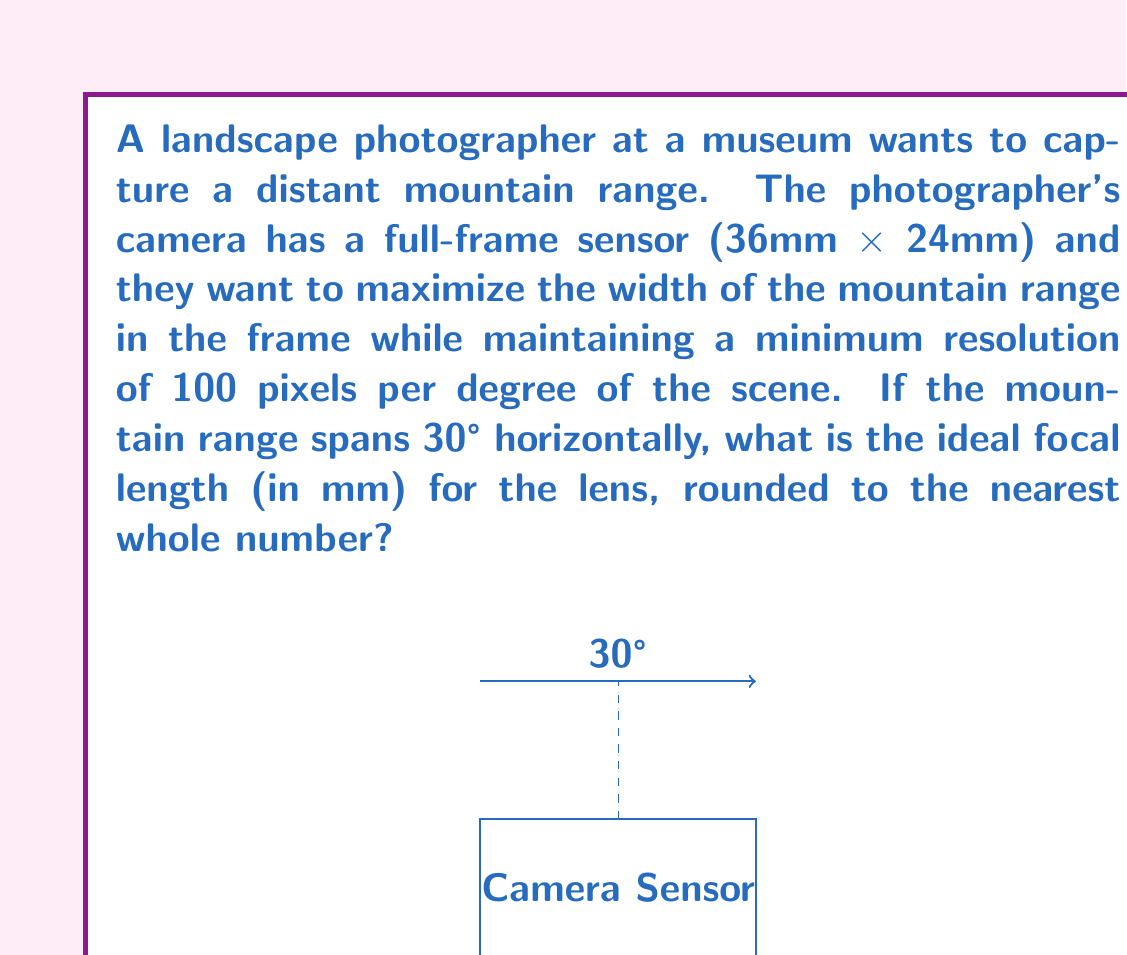Can you answer this question? Let's approach this step-by-step:

1) First, we need to understand the relationship between focal length and field of view. The horizontal field of view (FOV) in degrees is given by:

   $$FOV = 2 \cdot \arctan(\frac{sensor width}{2f})$$

   where $f$ is the focal length.

2) We know that the mountain range spans 30°, so this should be our FOV:

   $$30° = 2 \cdot \arctan(\frac{36}{2f})$$

3) We can solve this for $f$:

   $$\tan(15°) = \frac{18}{f}$$
   $$f = \frac{18}{\tan(15°)} \approx 67.38 \text{ mm}$$

4) Now, we need to check if this meets our resolution requirement. The number of pixels across the sensor width is:

   $$\text{pixels} = 30° \cdot 100 \text{ pixels/degree} = 3000 \text{ pixels}$$

5) The actual sensor width is 36mm, so our resolution is:

   $$\text{resolution} = \frac{3000 \text{ pixels}}{36 \text{ mm}} \approx 83.33 \text{ pixels/mm}$$

6) This is more than sufficient for most modern digital cameras, so our calculated focal length meets all requirements.

7) Rounding to the nearest whole number, we get 67 mm.
Answer: 67 mm 